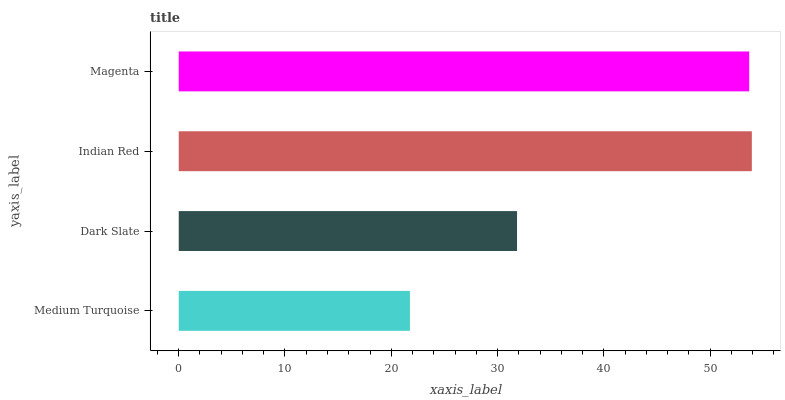Is Medium Turquoise the minimum?
Answer yes or no. Yes. Is Indian Red the maximum?
Answer yes or no. Yes. Is Dark Slate the minimum?
Answer yes or no. No. Is Dark Slate the maximum?
Answer yes or no. No. Is Dark Slate greater than Medium Turquoise?
Answer yes or no. Yes. Is Medium Turquoise less than Dark Slate?
Answer yes or no. Yes. Is Medium Turquoise greater than Dark Slate?
Answer yes or no. No. Is Dark Slate less than Medium Turquoise?
Answer yes or no. No. Is Magenta the high median?
Answer yes or no. Yes. Is Dark Slate the low median?
Answer yes or no. Yes. Is Medium Turquoise the high median?
Answer yes or no. No. Is Magenta the low median?
Answer yes or no. No. 